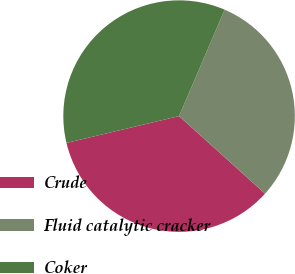<chart> <loc_0><loc_0><loc_500><loc_500><pie_chart><fcel>Crude<fcel>Fluid catalytic cracker<fcel>Coker<nl><fcel>34.6%<fcel>30.25%<fcel>35.16%<nl></chart> 